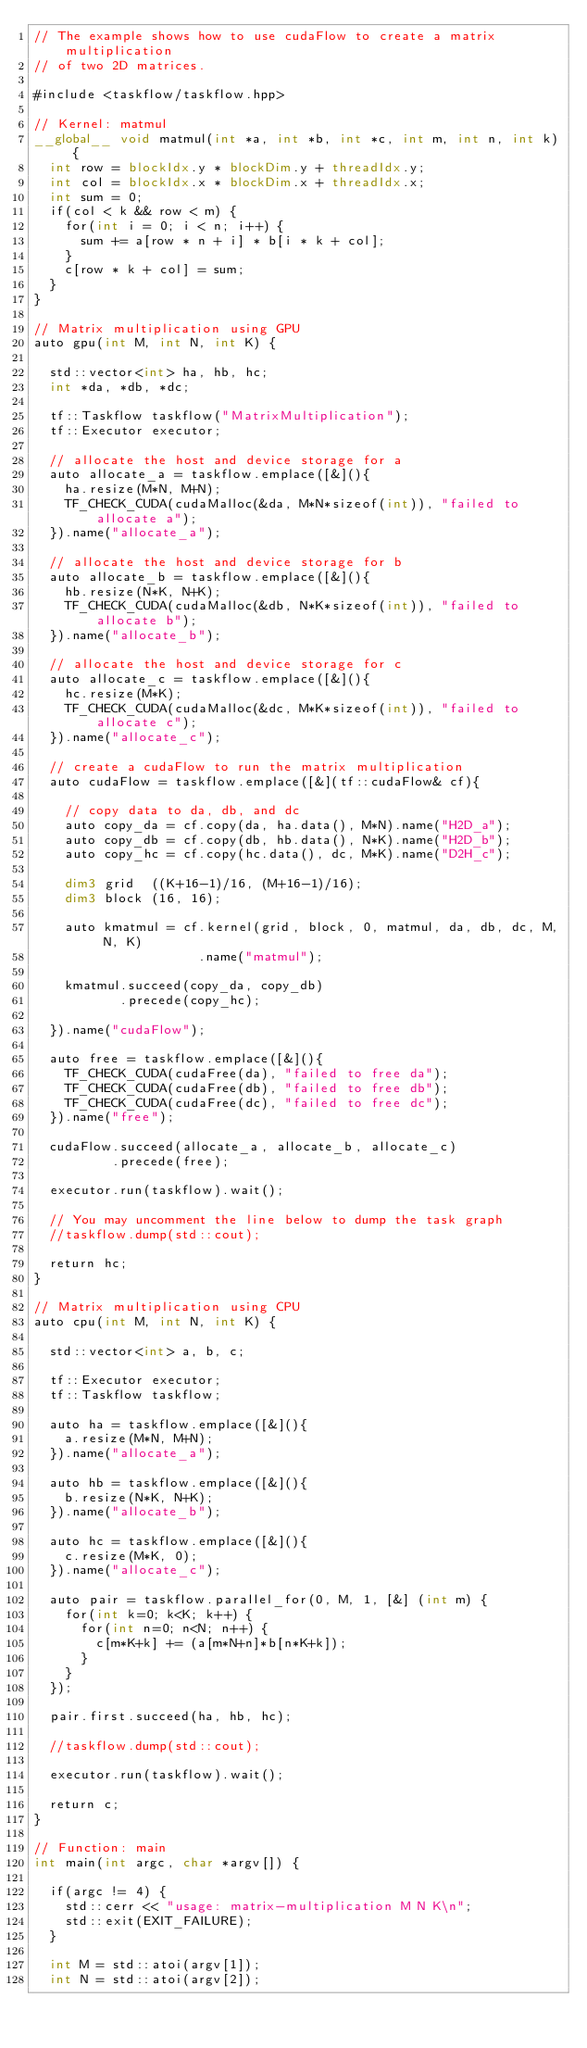<code> <loc_0><loc_0><loc_500><loc_500><_Cuda_>// The example shows how to use cudaFlow to create a matrix multiplication
// of two 2D matrices.

#include <taskflow/taskflow.hpp>

// Kernel: matmul
__global__ void matmul(int *a, int *b, int *c, int m, int n, int k) {
  int row = blockIdx.y * blockDim.y + threadIdx.y;
  int col = blockIdx.x * blockDim.x + threadIdx.x;
  int sum = 0;
  if(col < k && row < m) {
    for(int i = 0; i < n; i++) {
      sum += a[row * n + i] * b[i * k + col];
    }
    c[row * k + col] = sum;
  }
}

// Matrix multiplication using GPU
auto gpu(int M, int N, int K) {
  
  std::vector<int> ha, hb, hc;
  int *da, *db, *dc;

  tf::Taskflow taskflow("MatrixMultiplication");
  tf::Executor executor;

  // allocate the host and device storage for a
  auto allocate_a = taskflow.emplace([&](){
    ha.resize(M*N, M+N);
    TF_CHECK_CUDA(cudaMalloc(&da, M*N*sizeof(int)), "failed to allocate a");
  }).name("allocate_a");
  
  // allocate the host and device storage for b
  auto allocate_b = taskflow.emplace([&](){
    hb.resize(N*K, N+K);
    TF_CHECK_CUDA(cudaMalloc(&db, N*K*sizeof(int)), "failed to allocate b");
  }).name("allocate_b");
  
  // allocate the host and device storage for c
  auto allocate_c = taskflow.emplace([&](){
    hc.resize(M*K);
    TF_CHECK_CUDA(cudaMalloc(&dc, M*K*sizeof(int)), "failed to allocate c");
  }).name("allocate_c");
  
  // create a cudaFlow to run the matrix multiplication
  auto cudaFlow = taskflow.emplace([&](tf::cudaFlow& cf){

    // copy data to da, db, and dc
    auto copy_da = cf.copy(da, ha.data(), M*N).name("H2D_a");
    auto copy_db = cf.copy(db, hb.data(), N*K).name("H2D_b");
    auto copy_hc = cf.copy(hc.data(), dc, M*K).name("D2H_c"); 
    
    dim3 grid  ((K+16-1)/16, (M+16-1)/16);
    dim3 block (16, 16);

    auto kmatmul = cf.kernel(grid, block, 0, matmul, da, db, dc, M, N, K)
                     .name("matmul");

    kmatmul.succeed(copy_da, copy_db)
           .precede(copy_hc);

  }).name("cudaFlow");

  auto free = taskflow.emplace([&](){
    TF_CHECK_CUDA(cudaFree(da), "failed to free da");  
    TF_CHECK_CUDA(cudaFree(db), "failed to free db");  
    TF_CHECK_CUDA(cudaFree(dc), "failed to free dc");  
  }).name("free");

  cudaFlow.succeed(allocate_a, allocate_b, allocate_c)
          .precede(free);

  executor.run(taskflow).wait();
  
  // You may uncomment the line below to dump the task graph
  //taskflow.dump(std::cout);

  return hc;
}

// Matrix multiplication using CPU
auto cpu(int M, int N, int K) {  

  std::vector<int> a, b, c;

  tf::Executor executor;
  tf::Taskflow taskflow;

  auto ha = taskflow.emplace([&](){ 
    a.resize(M*N, M+N);
  }).name("allocate_a");

  auto hb = taskflow.emplace([&](){ 
    b.resize(N*K, N+K);
  }).name("allocate_b");

  auto hc = taskflow.emplace([&](){
    c.resize(M*K, 0);
  }).name("allocate_c");

  auto pair = taskflow.parallel_for(0, M, 1, [&] (int m) {
    for(int k=0; k<K; k++) {
      for(int n=0; n<N; n++) {
        c[m*K+k] += (a[m*N+n]*b[n*K+k]);
      }
    }
  });
  
  pair.first.succeed(ha, hb, hc);

  //taskflow.dump(std::cout);

  executor.run(taskflow).wait();

  return c;
}

// Function: main
int main(int argc, char *argv[]) {
  
  if(argc != 4) {
    std::cerr << "usage: matrix-multiplication M N K\n";
    std::exit(EXIT_FAILURE);
  }

  int M = std::atoi(argv[1]); 
  int N = std::atoi(argv[2]); </code> 